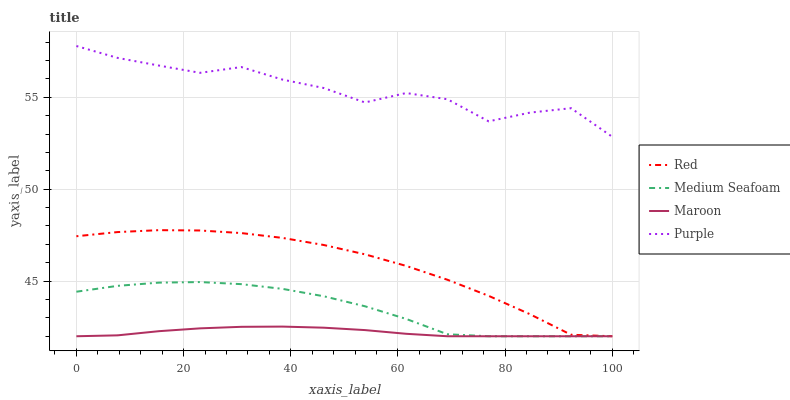Does Maroon have the minimum area under the curve?
Answer yes or no. Yes. Does Purple have the maximum area under the curve?
Answer yes or no. Yes. Does Medium Seafoam have the minimum area under the curve?
Answer yes or no. No. Does Medium Seafoam have the maximum area under the curve?
Answer yes or no. No. Is Maroon the smoothest?
Answer yes or no. Yes. Is Purple the roughest?
Answer yes or no. Yes. Is Medium Seafoam the smoothest?
Answer yes or no. No. Is Medium Seafoam the roughest?
Answer yes or no. No. Does Purple have the highest value?
Answer yes or no. Yes. Does Medium Seafoam have the highest value?
Answer yes or no. No. Is Maroon less than Purple?
Answer yes or no. Yes. Is Purple greater than Maroon?
Answer yes or no. Yes. Does Medium Seafoam intersect Red?
Answer yes or no. Yes. Is Medium Seafoam less than Red?
Answer yes or no. No. Is Medium Seafoam greater than Red?
Answer yes or no. No. Does Maroon intersect Purple?
Answer yes or no. No. 